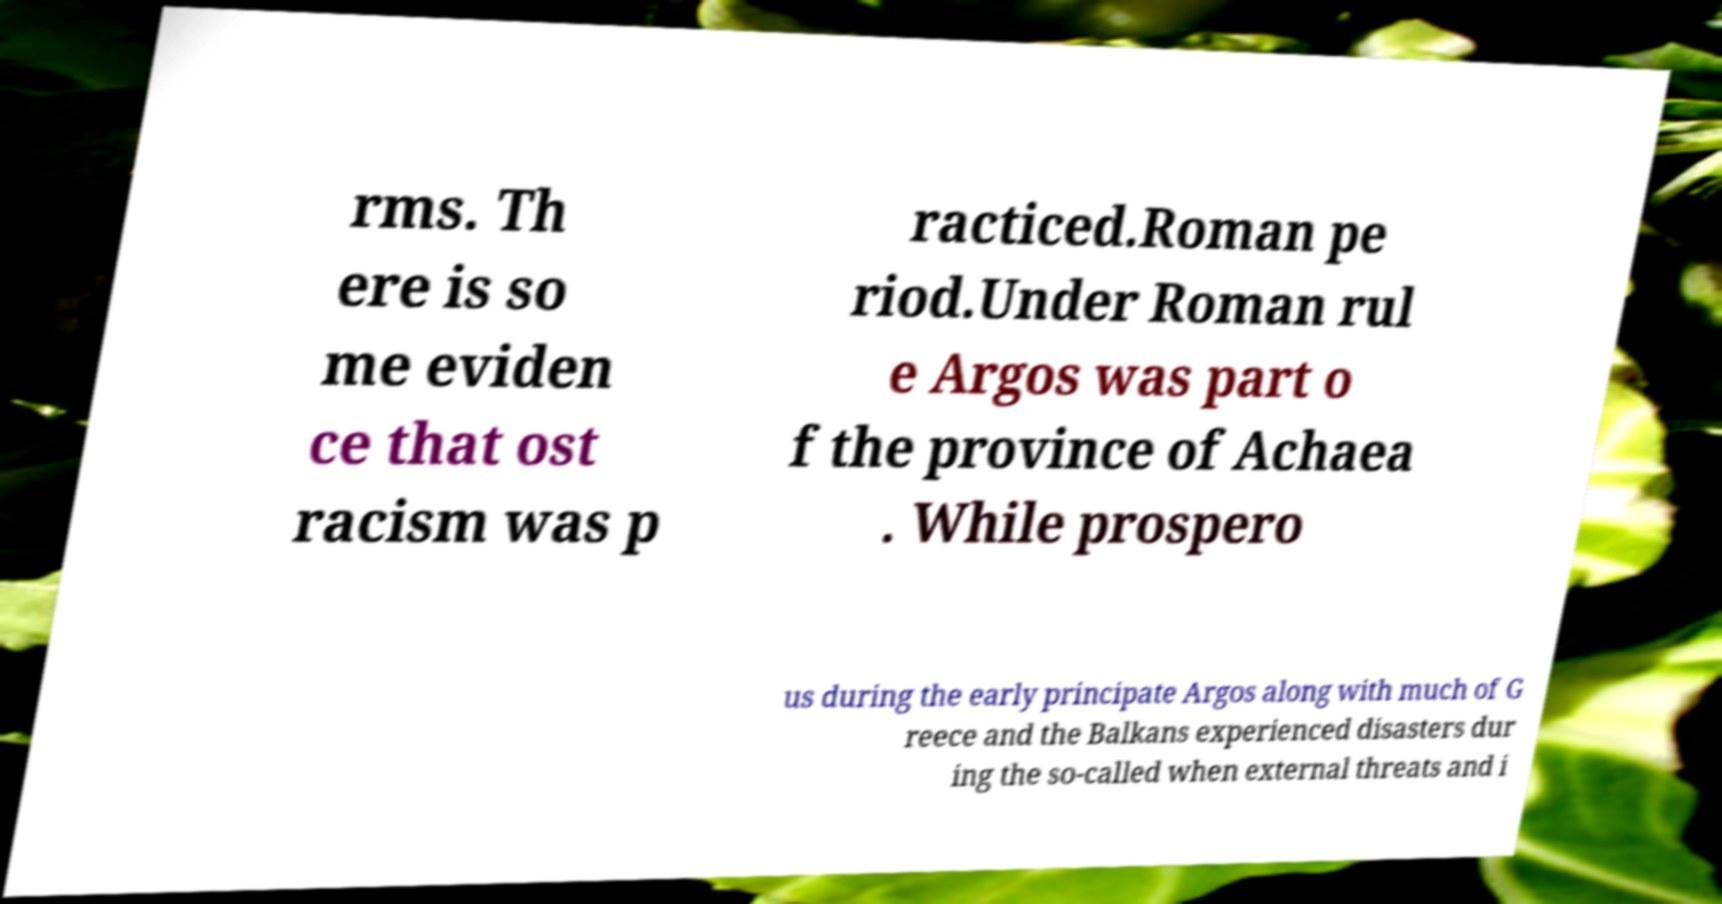I need the written content from this picture converted into text. Can you do that? rms. Th ere is so me eviden ce that ost racism was p racticed.Roman pe riod.Under Roman rul e Argos was part o f the province of Achaea . While prospero us during the early principate Argos along with much of G reece and the Balkans experienced disasters dur ing the so-called when external threats and i 